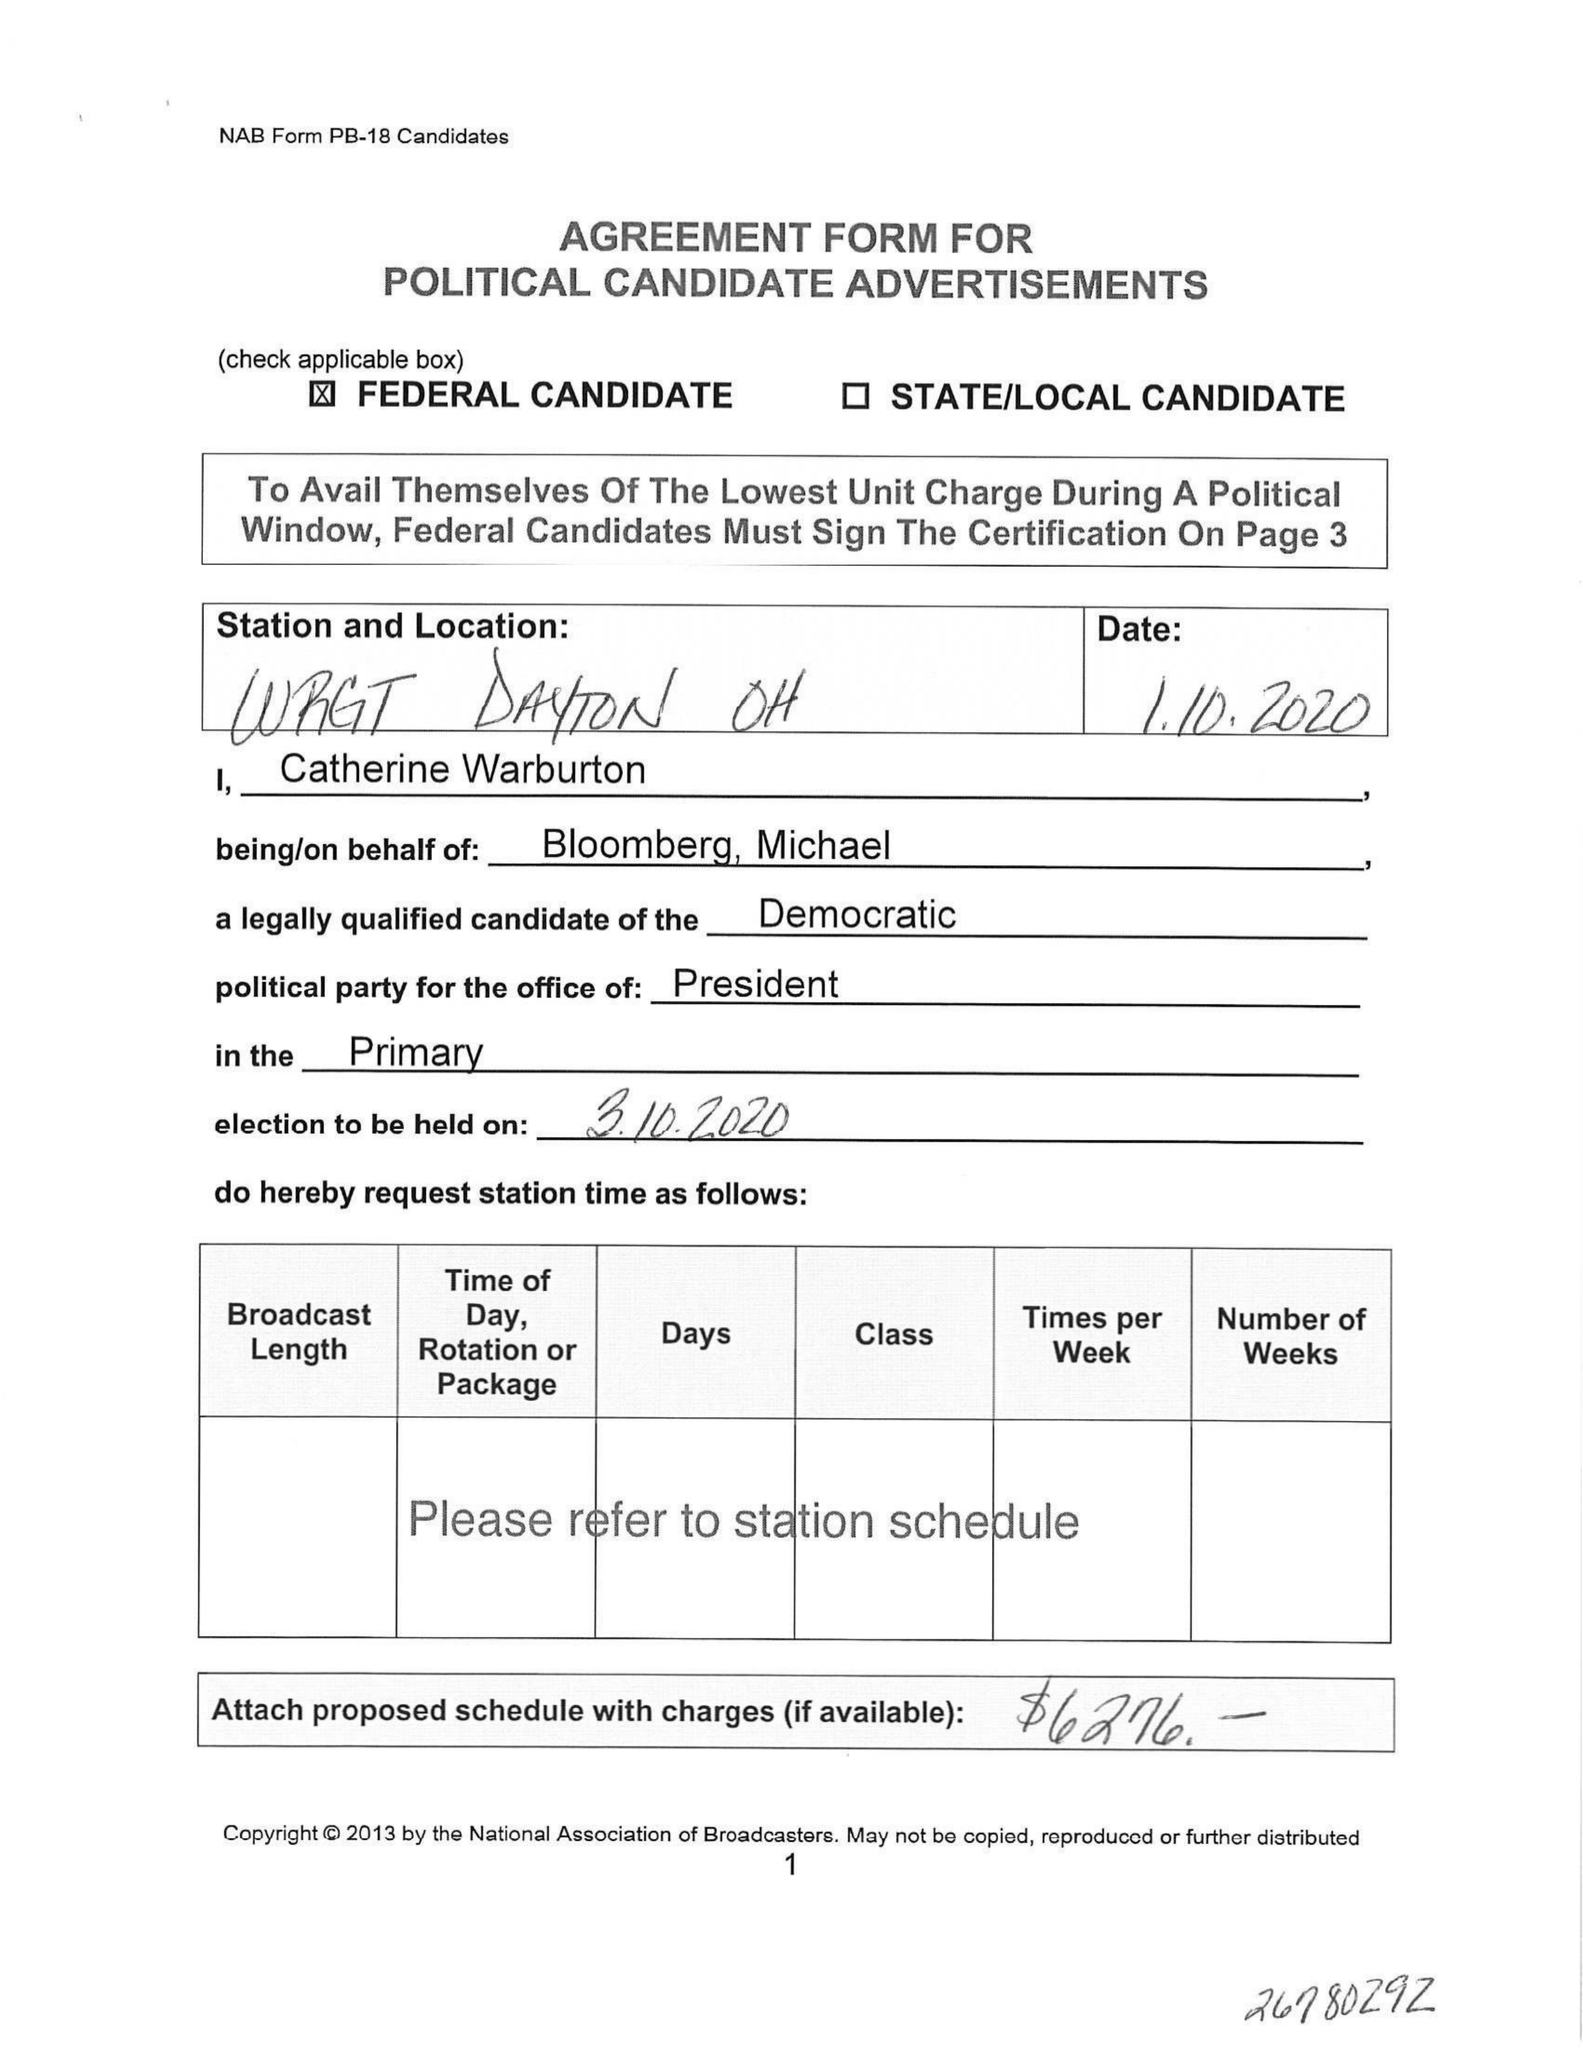What is the value for the advertiser?
Answer the question using a single word or phrase. None 